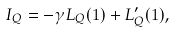Convert formula to latex. <formula><loc_0><loc_0><loc_500><loc_500>I _ { Q } = - \gamma L _ { Q } ( 1 ) + L _ { Q } ^ { \prime } ( 1 ) ,</formula> 